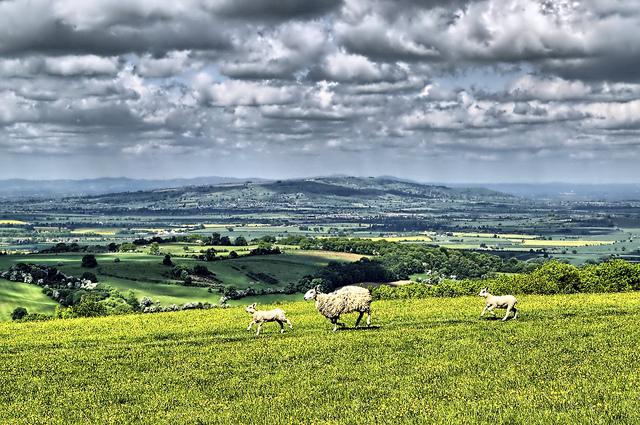What does the sky look like?
Answer briefly. Cloudy. Is this a rural scene?
Write a very short answer. Yes. What are the sheep doing?
Concise answer only. Running. 